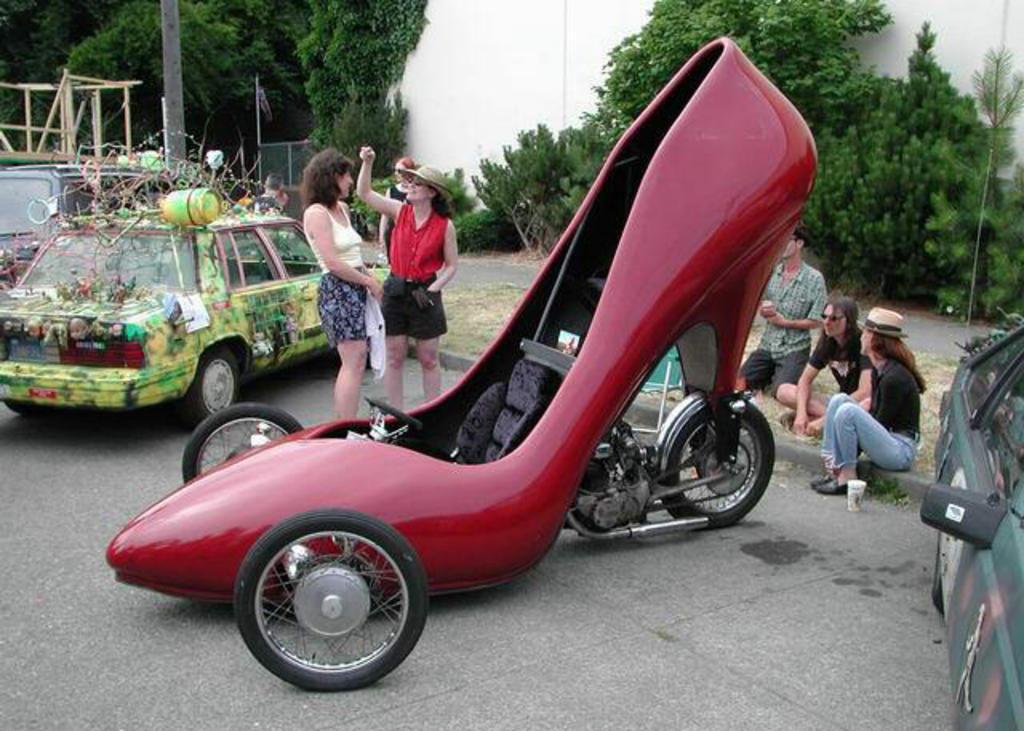How would you summarize this image in a sentence or two? There is a shoe model vehicle in the foreground in red color, there are people, greenery and vehicles on both the sides, it seems like toys and other items on the car on the left side. 